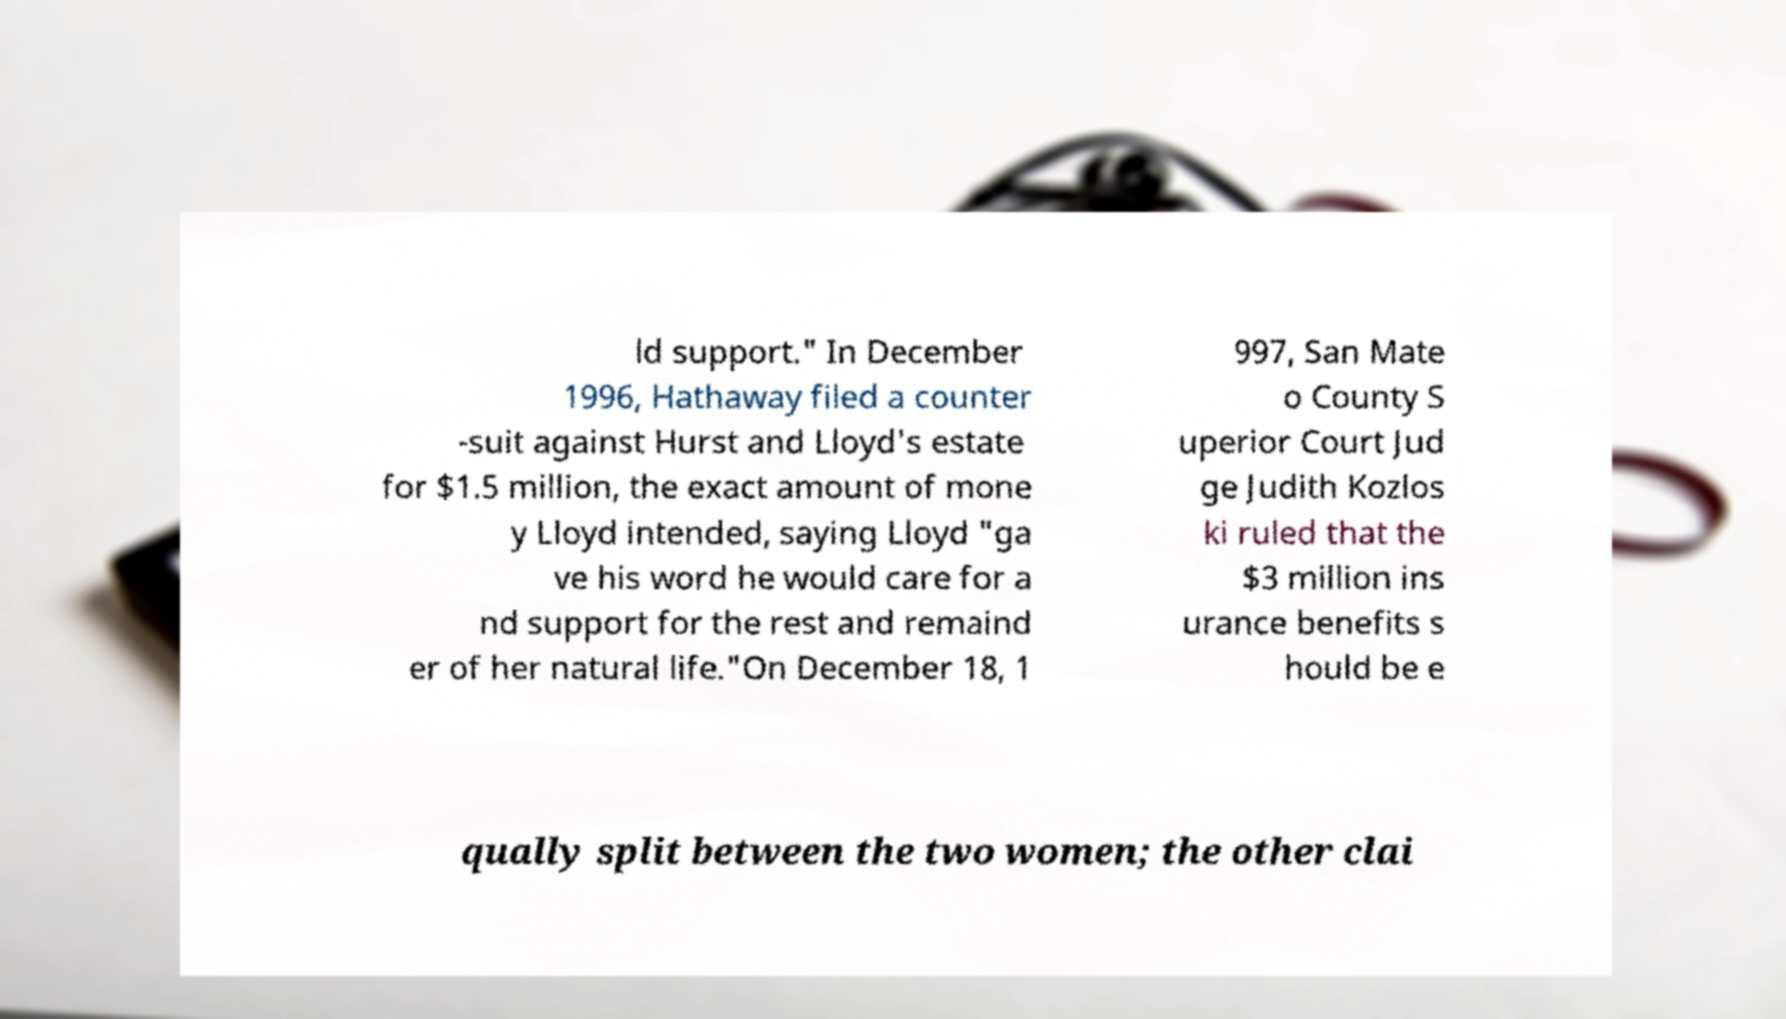Please read and relay the text visible in this image. What does it say? ld support." In December 1996, Hathaway filed a counter -suit against Hurst and Lloyd's estate for $1.5 million, the exact amount of mone y Lloyd intended, saying Lloyd "ga ve his word he would care for a nd support for the rest and remaind er of her natural life."On December 18, 1 997, San Mate o County S uperior Court Jud ge Judith Kozlos ki ruled that the $3 million ins urance benefits s hould be e qually split between the two women; the other clai 